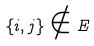<formula> <loc_0><loc_0><loc_500><loc_500>\{ i , j \} \notin E</formula> 